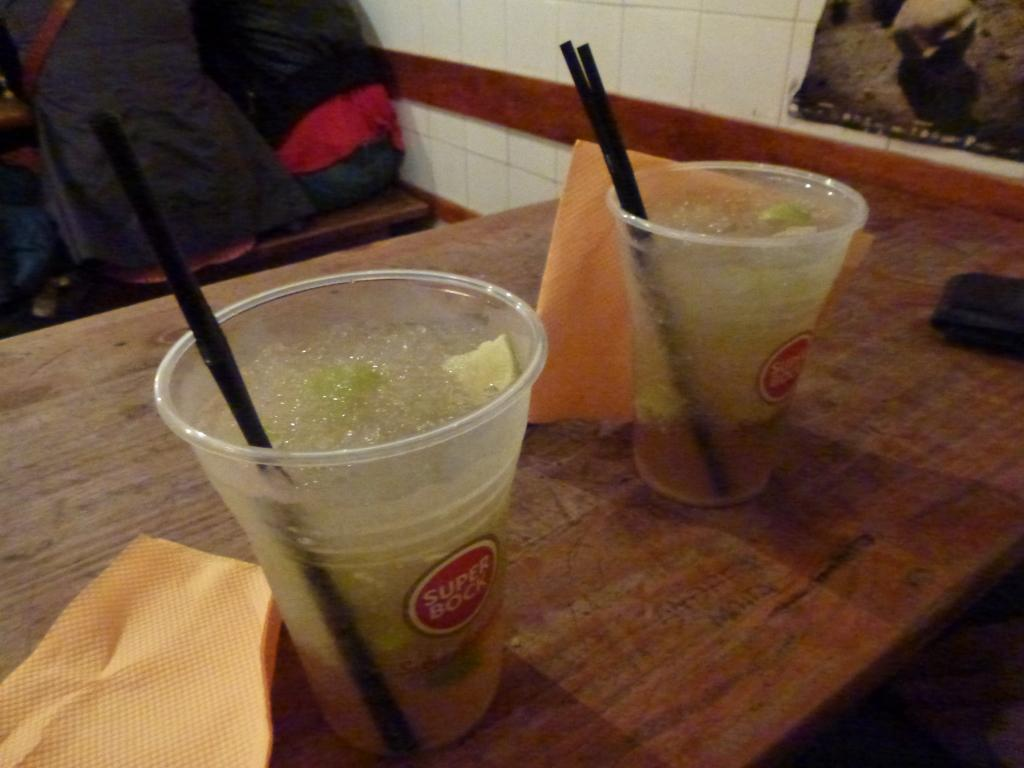What is the main piece of furniture in the image? There is a table in the image. What objects are on the table? There are two glasses on the table, and they contain juice. What else can be seen on the table? Tissue papers are present on the table. What is visible in the background of the image? There is a wall in the background of the image. What songs are being sung by the glasses in the image? The glasses do not sing songs in the image; they are simply holding juice. 